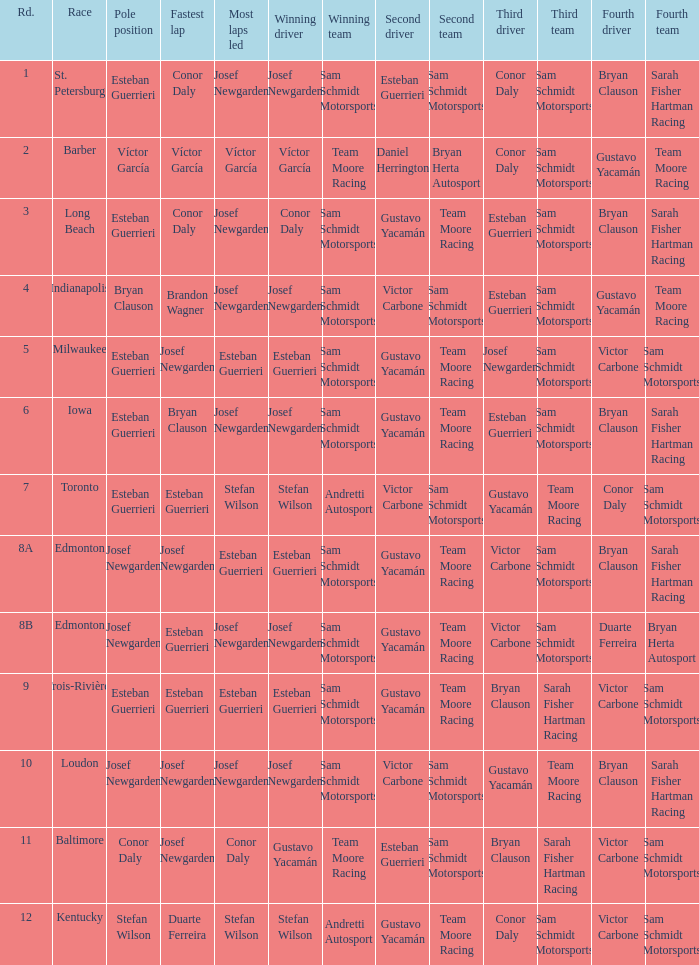Who led the most laps when brandon wagner had the fastest lap? Josef Newgarden. 